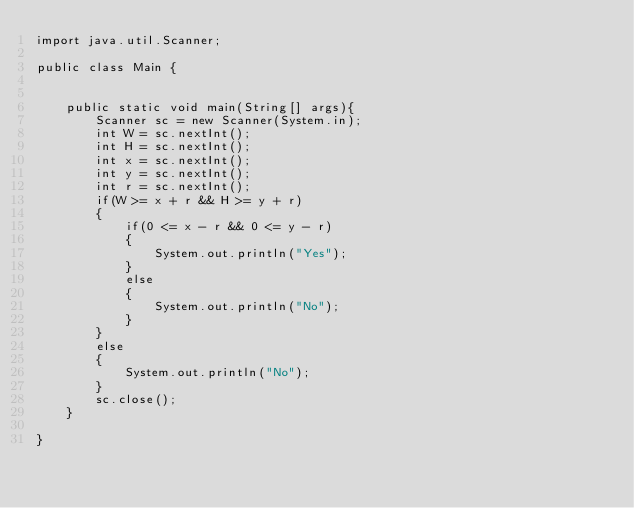<code> <loc_0><loc_0><loc_500><loc_500><_Java_>import java.util.Scanner;

public class Main {


    public static void main(String[] args){
		Scanner sc = new Scanner(System.in);
    	int W = sc.nextInt();
    	int H = sc.nextInt();
    	int x = sc.nextInt();
    	int y = sc.nextInt();
    	int r = sc.nextInt();
    	if(W >= x + r && H >= y + r)
    	{
        	if(0 <= x - r && 0 <= y - r)
        	{
        		System.out.println("Yes");
        	}
        	else
        	{
        		System.out.println("No");
        	}
    	}
    	else
    	{
    		System.out.println("No");
    	}
        sc.close();
    }

}</code> 